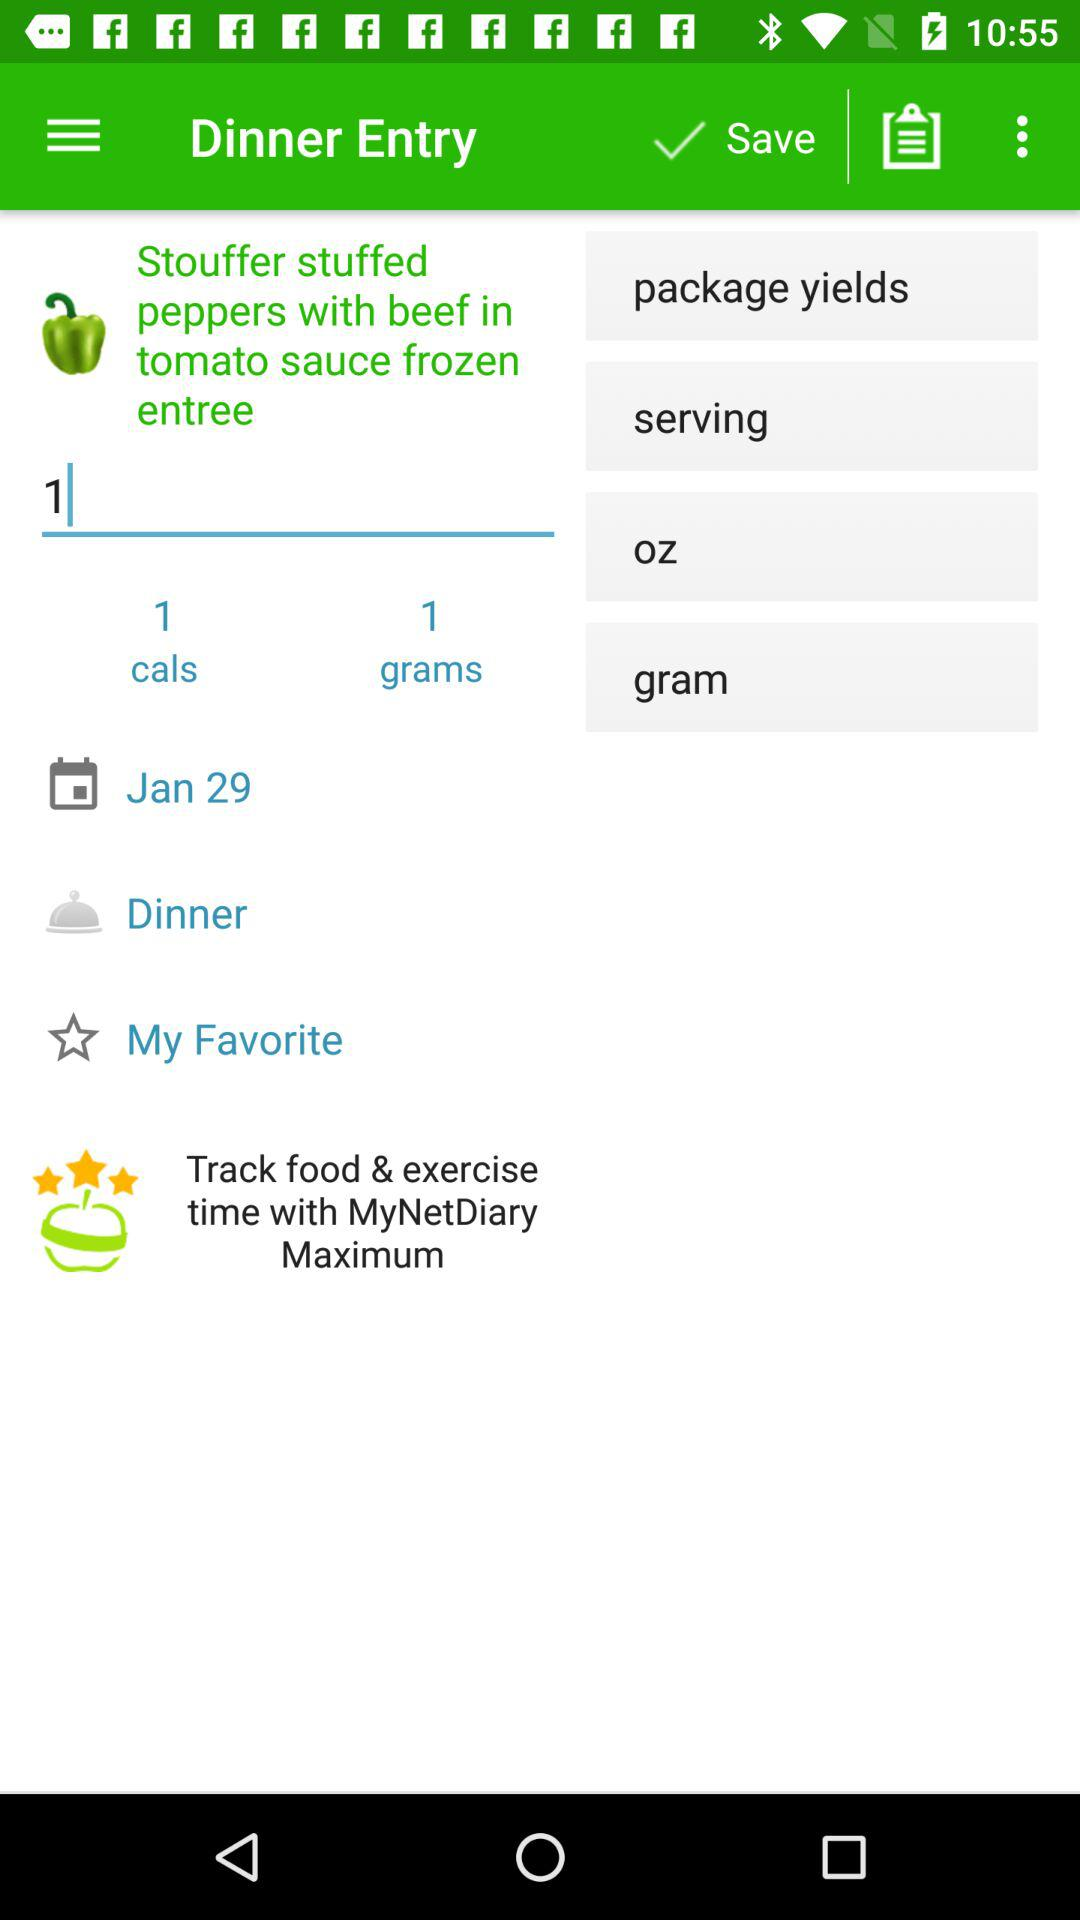How many grams are in the serving?
Answer the question using a single word or phrase. 1 